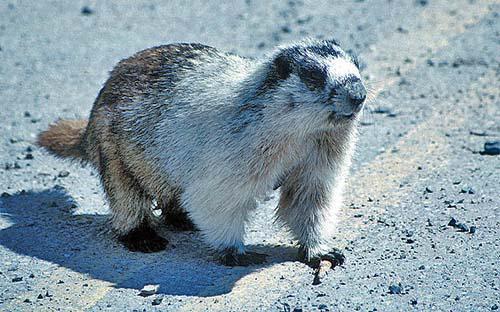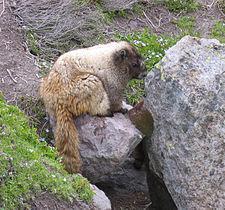The first image is the image on the left, the second image is the image on the right. Considering the images on both sides, is "the left and right image contains the same number of prairie dogs with long brown tales." valid? Answer yes or no. Yes. The first image is the image on the left, the second image is the image on the right. Given the left and right images, does the statement "The right image contains one small animal facing leftward, with its body flat on a rock and its brown tail angled downward." hold true? Answer yes or no. No. 